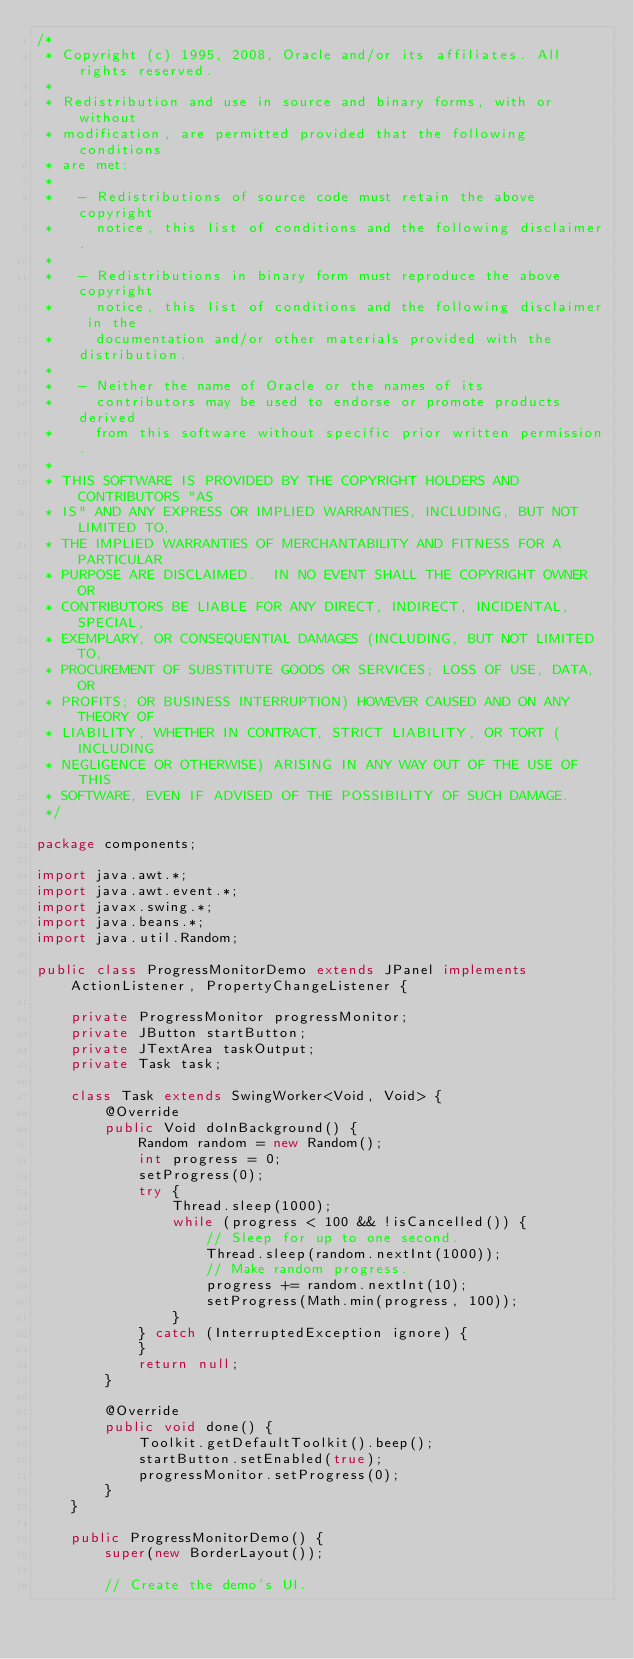<code> <loc_0><loc_0><loc_500><loc_500><_Java_>/*
 * Copyright (c) 1995, 2008, Oracle and/or its affiliates. All rights reserved.
 *
 * Redistribution and use in source and binary forms, with or without
 * modification, are permitted provided that the following conditions
 * are met:
 *
 *   - Redistributions of source code must retain the above copyright
 *     notice, this list of conditions and the following disclaimer.
 *
 *   - Redistributions in binary form must reproduce the above copyright
 *     notice, this list of conditions and the following disclaimer in the
 *     documentation and/or other materials provided with the distribution.
 *
 *   - Neither the name of Oracle or the names of its
 *     contributors may be used to endorse or promote products derived
 *     from this software without specific prior written permission.
 *
 * THIS SOFTWARE IS PROVIDED BY THE COPYRIGHT HOLDERS AND CONTRIBUTORS "AS
 * IS" AND ANY EXPRESS OR IMPLIED WARRANTIES, INCLUDING, BUT NOT LIMITED TO,
 * THE IMPLIED WARRANTIES OF MERCHANTABILITY AND FITNESS FOR A PARTICULAR
 * PURPOSE ARE DISCLAIMED.  IN NO EVENT SHALL THE COPYRIGHT OWNER OR
 * CONTRIBUTORS BE LIABLE FOR ANY DIRECT, INDIRECT, INCIDENTAL, SPECIAL,
 * EXEMPLARY, OR CONSEQUENTIAL DAMAGES (INCLUDING, BUT NOT LIMITED TO,
 * PROCUREMENT OF SUBSTITUTE GOODS OR SERVICES; LOSS OF USE, DATA, OR
 * PROFITS; OR BUSINESS INTERRUPTION) HOWEVER CAUSED AND ON ANY THEORY OF
 * LIABILITY, WHETHER IN CONTRACT, STRICT LIABILITY, OR TORT (INCLUDING
 * NEGLIGENCE OR OTHERWISE) ARISING IN ANY WAY OUT OF THE USE OF THIS
 * SOFTWARE, EVEN IF ADVISED OF THE POSSIBILITY OF SUCH DAMAGE.
 */

package components;

import java.awt.*;
import java.awt.event.*;
import javax.swing.*;
import java.beans.*;
import java.util.Random;

public class ProgressMonitorDemo extends JPanel implements ActionListener, PropertyChangeListener {

    private ProgressMonitor progressMonitor;
    private JButton startButton;
    private JTextArea taskOutput;
    private Task task;

    class Task extends SwingWorker<Void, Void> {
        @Override
        public Void doInBackground() {
            Random random = new Random();
            int progress = 0;
            setProgress(0);
            try {
                Thread.sleep(1000);
                while (progress < 100 && !isCancelled()) {
                    // Sleep for up to one second.
                    Thread.sleep(random.nextInt(1000));
                    // Make random progress.
                    progress += random.nextInt(10);
                    setProgress(Math.min(progress, 100));
                }
            } catch (InterruptedException ignore) {
            }
            return null;
        }

        @Override
        public void done() {
            Toolkit.getDefaultToolkit().beep();
            startButton.setEnabled(true);
            progressMonitor.setProgress(0);
        }
    }

    public ProgressMonitorDemo() {
        super(new BorderLayout());

        // Create the demo's UI.</code> 